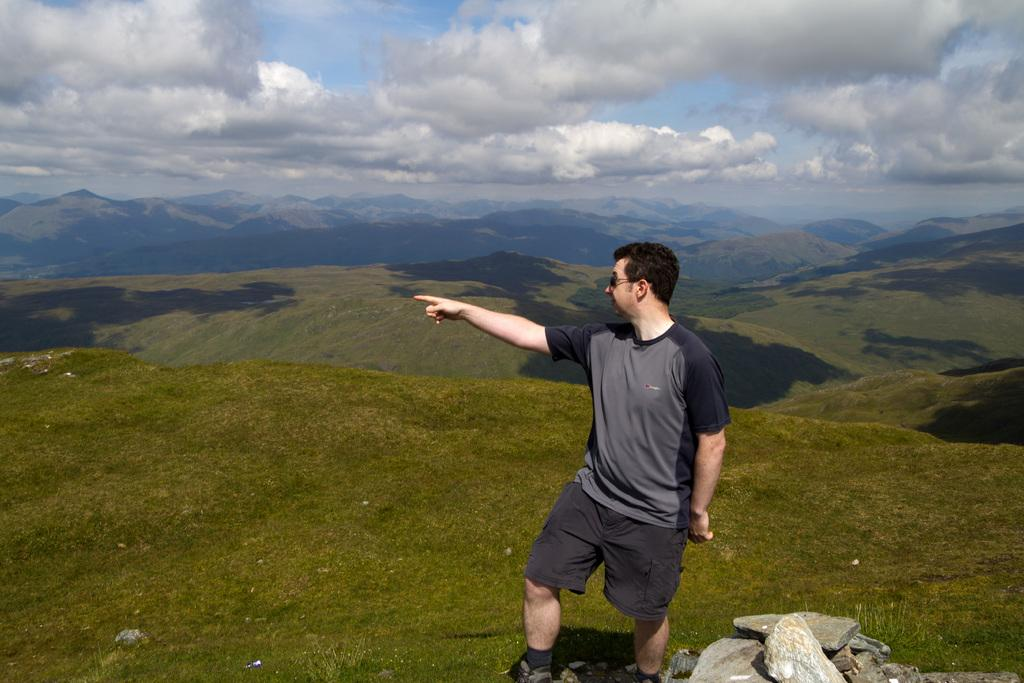What is the weather like in the image? The sky is cloudy in the image. What is the man in the image doing? The man is pointing towards the left side of the image. What type of vegetation covers the land in the image? The land is covered with grass in the image. What can be seen in the distance in the image? There are hills visible in the background of the image. What type of hose is the man using to respect the dog in the image? There is no hose or dog present in the image. How does the man show respect to the dog in the image? The image does not depict any interaction between the man and a dog, nor does it show any sign of respect. 